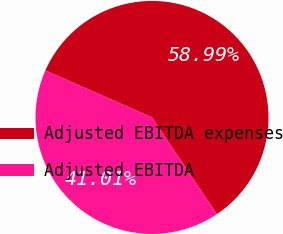Convert chart. <chart><loc_0><loc_0><loc_500><loc_500><pie_chart><fcel>Adjusted EBITDA expenses<fcel>Adjusted EBITDA<nl><fcel>58.99%<fcel>41.01%<nl></chart> 